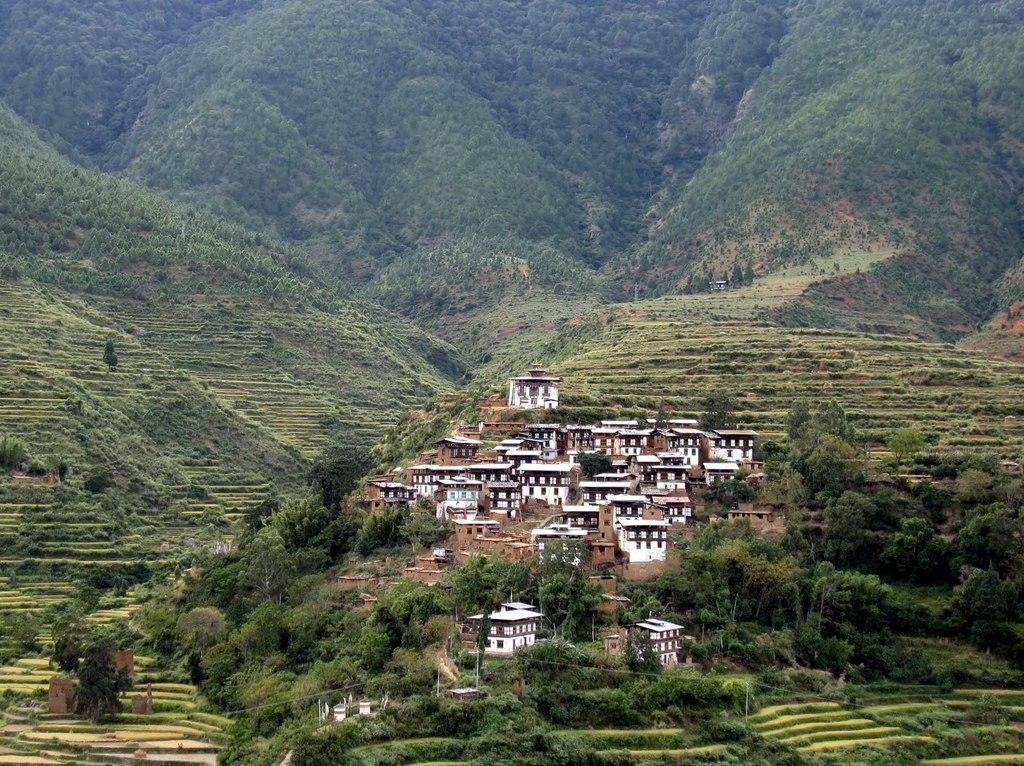How would you summarize this image in a sentence or two? This is an outside view. In the middle of the image I can see few buildings and many trees. At the top of the image I can see the hills. 